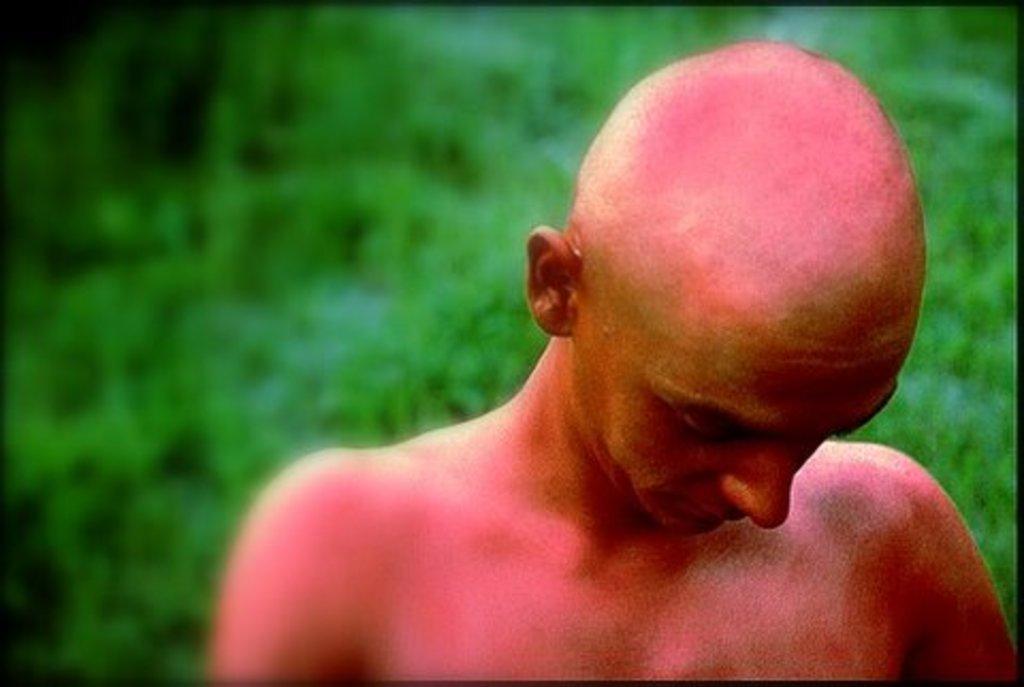Please provide a concise description of this image. In this picture there is a bald man with shirtless is standing in front of the image. Behind there is a green blur background. 